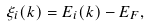Convert formula to latex. <formula><loc_0><loc_0><loc_500><loc_500>\xi _ { i } ( { k } ) = E _ { i } ( { k } ) - E _ { F } ,</formula> 